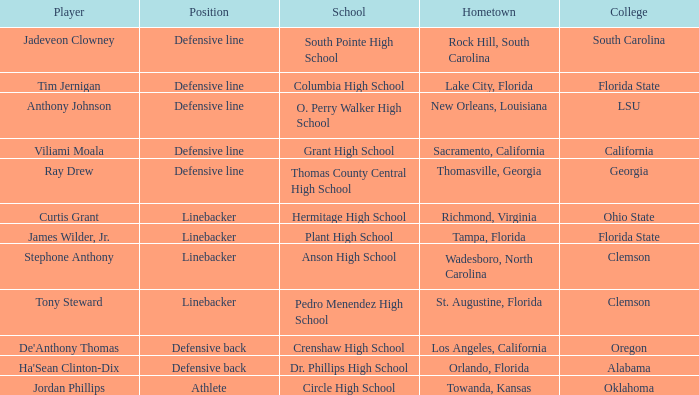Give me the full table as a dictionary. {'header': ['Player', 'Position', 'School', 'Hometown', 'College'], 'rows': [['Jadeveon Clowney', 'Defensive line', 'South Pointe High School', 'Rock Hill, South Carolina', 'South Carolina'], ['Tim Jernigan', 'Defensive line', 'Columbia High School', 'Lake City, Florida', 'Florida State'], ['Anthony Johnson', 'Defensive line', 'O. Perry Walker High School', 'New Orleans, Louisiana', 'LSU'], ['Viliami Moala', 'Defensive line', 'Grant High School', 'Sacramento, California', 'California'], ['Ray Drew', 'Defensive line', 'Thomas County Central High School', 'Thomasville, Georgia', 'Georgia'], ['Curtis Grant', 'Linebacker', 'Hermitage High School', 'Richmond, Virginia', 'Ohio State'], ['James Wilder, Jr.', 'Linebacker', 'Plant High School', 'Tampa, Florida', 'Florida State'], ['Stephone Anthony', 'Linebacker', 'Anson High School', 'Wadesboro, North Carolina', 'Clemson'], ['Tony Steward', 'Linebacker', 'Pedro Menendez High School', 'St. Augustine, Florida', 'Clemson'], ["De'Anthony Thomas", 'Defensive back', 'Crenshaw High School', 'Los Angeles, California', 'Oregon'], ["Ha'Sean Clinton-Dix", 'Defensive back', 'Dr. Phillips High School', 'Orlando, Florida', 'Alabama'], ['Jordan Phillips', 'Athlete', 'Circle High School', 'Towanda, Kansas', 'Oklahoma']]} What college has a position of defensive line and Grant high school? California. 